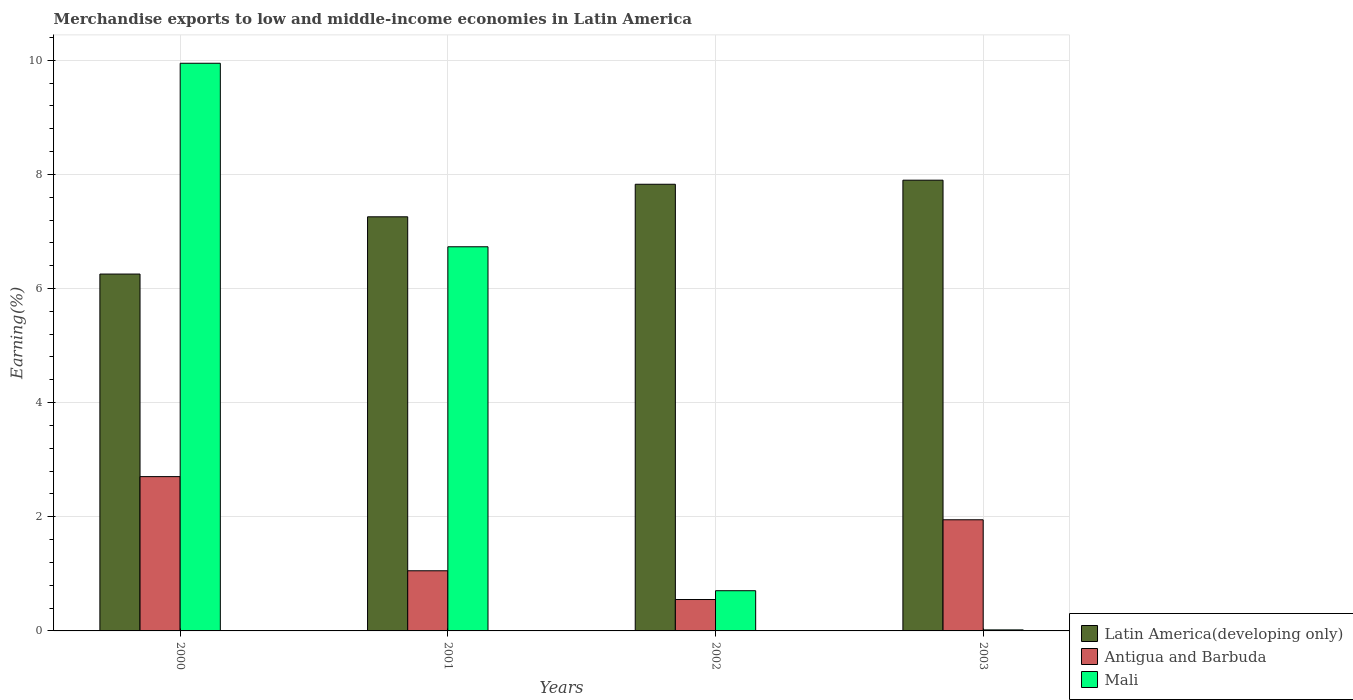How many groups of bars are there?
Offer a terse response. 4. Are the number of bars per tick equal to the number of legend labels?
Make the answer very short. Yes. Are the number of bars on each tick of the X-axis equal?
Offer a very short reply. Yes. How many bars are there on the 4th tick from the left?
Offer a terse response. 3. How many bars are there on the 3rd tick from the right?
Your answer should be compact. 3. What is the percentage of amount earned from merchandise exports in Antigua and Barbuda in 2003?
Your answer should be very brief. 1.95. Across all years, what is the maximum percentage of amount earned from merchandise exports in Antigua and Barbuda?
Offer a terse response. 2.7. Across all years, what is the minimum percentage of amount earned from merchandise exports in Mali?
Keep it short and to the point. 0.02. In which year was the percentage of amount earned from merchandise exports in Antigua and Barbuda maximum?
Offer a terse response. 2000. What is the total percentage of amount earned from merchandise exports in Latin America(developing only) in the graph?
Keep it short and to the point. 29.24. What is the difference between the percentage of amount earned from merchandise exports in Antigua and Barbuda in 2001 and that in 2002?
Offer a terse response. 0.5. What is the difference between the percentage of amount earned from merchandise exports in Latin America(developing only) in 2003 and the percentage of amount earned from merchandise exports in Mali in 2001?
Offer a very short reply. 1.17. What is the average percentage of amount earned from merchandise exports in Antigua and Barbuda per year?
Your answer should be compact. 1.56. In the year 2003, what is the difference between the percentage of amount earned from merchandise exports in Latin America(developing only) and percentage of amount earned from merchandise exports in Antigua and Barbuda?
Offer a very short reply. 5.95. In how many years, is the percentage of amount earned from merchandise exports in Latin America(developing only) greater than 6.8 %?
Offer a very short reply. 3. What is the ratio of the percentage of amount earned from merchandise exports in Antigua and Barbuda in 2000 to that in 2003?
Ensure brevity in your answer.  1.39. What is the difference between the highest and the second highest percentage of amount earned from merchandise exports in Latin America(developing only)?
Your answer should be very brief. 0.07. What is the difference between the highest and the lowest percentage of amount earned from merchandise exports in Latin America(developing only)?
Make the answer very short. 1.64. What does the 3rd bar from the left in 2001 represents?
Your answer should be very brief. Mali. What does the 1st bar from the right in 2003 represents?
Your answer should be compact. Mali. Is it the case that in every year, the sum of the percentage of amount earned from merchandise exports in Antigua and Barbuda and percentage of amount earned from merchandise exports in Latin America(developing only) is greater than the percentage of amount earned from merchandise exports in Mali?
Keep it short and to the point. No. How many bars are there?
Offer a terse response. 12. Are all the bars in the graph horizontal?
Your answer should be very brief. No. Are the values on the major ticks of Y-axis written in scientific E-notation?
Your answer should be very brief. No. Does the graph contain any zero values?
Your answer should be compact. No. Where does the legend appear in the graph?
Your answer should be compact. Bottom right. How many legend labels are there?
Ensure brevity in your answer.  3. How are the legend labels stacked?
Provide a succinct answer. Vertical. What is the title of the graph?
Your response must be concise. Merchandise exports to low and middle-income economies in Latin America. Does "Switzerland" appear as one of the legend labels in the graph?
Offer a terse response. No. What is the label or title of the Y-axis?
Offer a very short reply. Earning(%). What is the Earning(%) in Latin America(developing only) in 2000?
Ensure brevity in your answer.  6.25. What is the Earning(%) in Antigua and Barbuda in 2000?
Keep it short and to the point. 2.7. What is the Earning(%) of Mali in 2000?
Give a very brief answer. 9.95. What is the Earning(%) of Latin America(developing only) in 2001?
Give a very brief answer. 7.26. What is the Earning(%) of Antigua and Barbuda in 2001?
Provide a succinct answer. 1.05. What is the Earning(%) of Mali in 2001?
Ensure brevity in your answer.  6.73. What is the Earning(%) of Latin America(developing only) in 2002?
Make the answer very short. 7.83. What is the Earning(%) in Antigua and Barbuda in 2002?
Ensure brevity in your answer.  0.55. What is the Earning(%) of Mali in 2002?
Make the answer very short. 0.7. What is the Earning(%) of Latin America(developing only) in 2003?
Your answer should be very brief. 7.9. What is the Earning(%) of Antigua and Barbuda in 2003?
Provide a short and direct response. 1.95. What is the Earning(%) in Mali in 2003?
Make the answer very short. 0.02. Across all years, what is the maximum Earning(%) of Latin America(developing only)?
Give a very brief answer. 7.9. Across all years, what is the maximum Earning(%) of Antigua and Barbuda?
Provide a succinct answer. 2.7. Across all years, what is the maximum Earning(%) of Mali?
Offer a very short reply. 9.95. Across all years, what is the minimum Earning(%) of Latin America(developing only)?
Provide a succinct answer. 6.25. Across all years, what is the minimum Earning(%) of Antigua and Barbuda?
Ensure brevity in your answer.  0.55. Across all years, what is the minimum Earning(%) of Mali?
Offer a very short reply. 0.02. What is the total Earning(%) of Latin America(developing only) in the graph?
Your answer should be compact. 29.24. What is the total Earning(%) in Antigua and Barbuda in the graph?
Give a very brief answer. 6.26. What is the total Earning(%) of Mali in the graph?
Offer a very short reply. 17.4. What is the difference between the Earning(%) of Latin America(developing only) in 2000 and that in 2001?
Your response must be concise. -1. What is the difference between the Earning(%) of Antigua and Barbuda in 2000 and that in 2001?
Offer a very short reply. 1.65. What is the difference between the Earning(%) of Mali in 2000 and that in 2001?
Your answer should be very brief. 3.22. What is the difference between the Earning(%) of Latin America(developing only) in 2000 and that in 2002?
Your response must be concise. -1.57. What is the difference between the Earning(%) in Antigua and Barbuda in 2000 and that in 2002?
Make the answer very short. 2.15. What is the difference between the Earning(%) of Mali in 2000 and that in 2002?
Make the answer very short. 9.24. What is the difference between the Earning(%) of Latin America(developing only) in 2000 and that in 2003?
Your answer should be very brief. -1.65. What is the difference between the Earning(%) in Antigua and Barbuda in 2000 and that in 2003?
Offer a very short reply. 0.76. What is the difference between the Earning(%) of Mali in 2000 and that in 2003?
Your answer should be compact. 9.93. What is the difference between the Earning(%) in Latin America(developing only) in 2001 and that in 2002?
Offer a terse response. -0.57. What is the difference between the Earning(%) of Antigua and Barbuda in 2001 and that in 2002?
Provide a succinct answer. 0.5. What is the difference between the Earning(%) of Mali in 2001 and that in 2002?
Keep it short and to the point. 6.03. What is the difference between the Earning(%) in Latin America(developing only) in 2001 and that in 2003?
Your response must be concise. -0.64. What is the difference between the Earning(%) in Antigua and Barbuda in 2001 and that in 2003?
Your response must be concise. -0.89. What is the difference between the Earning(%) of Mali in 2001 and that in 2003?
Your response must be concise. 6.71. What is the difference between the Earning(%) of Latin America(developing only) in 2002 and that in 2003?
Provide a succinct answer. -0.07. What is the difference between the Earning(%) of Antigua and Barbuda in 2002 and that in 2003?
Keep it short and to the point. -1.4. What is the difference between the Earning(%) in Mali in 2002 and that in 2003?
Your response must be concise. 0.69. What is the difference between the Earning(%) of Latin America(developing only) in 2000 and the Earning(%) of Antigua and Barbuda in 2001?
Provide a succinct answer. 5.2. What is the difference between the Earning(%) in Latin America(developing only) in 2000 and the Earning(%) in Mali in 2001?
Provide a short and direct response. -0.48. What is the difference between the Earning(%) of Antigua and Barbuda in 2000 and the Earning(%) of Mali in 2001?
Give a very brief answer. -4.03. What is the difference between the Earning(%) in Latin America(developing only) in 2000 and the Earning(%) in Antigua and Barbuda in 2002?
Your answer should be very brief. 5.7. What is the difference between the Earning(%) of Latin America(developing only) in 2000 and the Earning(%) of Mali in 2002?
Your answer should be very brief. 5.55. What is the difference between the Earning(%) in Antigua and Barbuda in 2000 and the Earning(%) in Mali in 2002?
Your response must be concise. 2. What is the difference between the Earning(%) of Latin America(developing only) in 2000 and the Earning(%) of Antigua and Barbuda in 2003?
Provide a succinct answer. 4.31. What is the difference between the Earning(%) in Latin America(developing only) in 2000 and the Earning(%) in Mali in 2003?
Make the answer very short. 6.24. What is the difference between the Earning(%) of Antigua and Barbuda in 2000 and the Earning(%) of Mali in 2003?
Keep it short and to the point. 2.69. What is the difference between the Earning(%) of Latin America(developing only) in 2001 and the Earning(%) of Antigua and Barbuda in 2002?
Ensure brevity in your answer.  6.71. What is the difference between the Earning(%) of Latin America(developing only) in 2001 and the Earning(%) of Mali in 2002?
Make the answer very short. 6.55. What is the difference between the Earning(%) of Antigua and Barbuda in 2001 and the Earning(%) of Mali in 2002?
Make the answer very short. 0.35. What is the difference between the Earning(%) in Latin America(developing only) in 2001 and the Earning(%) in Antigua and Barbuda in 2003?
Your answer should be very brief. 5.31. What is the difference between the Earning(%) in Latin America(developing only) in 2001 and the Earning(%) in Mali in 2003?
Your answer should be very brief. 7.24. What is the difference between the Earning(%) in Antigua and Barbuda in 2001 and the Earning(%) in Mali in 2003?
Ensure brevity in your answer.  1.04. What is the difference between the Earning(%) of Latin America(developing only) in 2002 and the Earning(%) of Antigua and Barbuda in 2003?
Provide a succinct answer. 5.88. What is the difference between the Earning(%) of Latin America(developing only) in 2002 and the Earning(%) of Mali in 2003?
Offer a very short reply. 7.81. What is the difference between the Earning(%) of Antigua and Barbuda in 2002 and the Earning(%) of Mali in 2003?
Give a very brief answer. 0.53. What is the average Earning(%) in Latin America(developing only) per year?
Ensure brevity in your answer.  7.31. What is the average Earning(%) of Antigua and Barbuda per year?
Provide a succinct answer. 1.56. What is the average Earning(%) of Mali per year?
Give a very brief answer. 4.35. In the year 2000, what is the difference between the Earning(%) of Latin America(developing only) and Earning(%) of Antigua and Barbuda?
Your answer should be compact. 3.55. In the year 2000, what is the difference between the Earning(%) in Latin America(developing only) and Earning(%) in Mali?
Your answer should be very brief. -3.69. In the year 2000, what is the difference between the Earning(%) in Antigua and Barbuda and Earning(%) in Mali?
Ensure brevity in your answer.  -7.24. In the year 2001, what is the difference between the Earning(%) in Latin America(developing only) and Earning(%) in Antigua and Barbuda?
Make the answer very short. 6.2. In the year 2001, what is the difference between the Earning(%) of Latin America(developing only) and Earning(%) of Mali?
Your answer should be very brief. 0.53. In the year 2001, what is the difference between the Earning(%) in Antigua and Barbuda and Earning(%) in Mali?
Offer a very short reply. -5.68. In the year 2002, what is the difference between the Earning(%) of Latin America(developing only) and Earning(%) of Antigua and Barbuda?
Offer a terse response. 7.28. In the year 2002, what is the difference between the Earning(%) in Latin America(developing only) and Earning(%) in Mali?
Keep it short and to the point. 7.12. In the year 2002, what is the difference between the Earning(%) in Antigua and Barbuda and Earning(%) in Mali?
Your answer should be very brief. -0.15. In the year 2003, what is the difference between the Earning(%) of Latin America(developing only) and Earning(%) of Antigua and Barbuda?
Offer a very short reply. 5.95. In the year 2003, what is the difference between the Earning(%) of Latin America(developing only) and Earning(%) of Mali?
Your answer should be compact. 7.88. In the year 2003, what is the difference between the Earning(%) in Antigua and Barbuda and Earning(%) in Mali?
Keep it short and to the point. 1.93. What is the ratio of the Earning(%) of Latin America(developing only) in 2000 to that in 2001?
Ensure brevity in your answer.  0.86. What is the ratio of the Earning(%) in Antigua and Barbuda in 2000 to that in 2001?
Make the answer very short. 2.57. What is the ratio of the Earning(%) of Mali in 2000 to that in 2001?
Make the answer very short. 1.48. What is the ratio of the Earning(%) of Latin America(developing only) in 2000 to that in 2002?
Make the answer very short. 0.8. What is the ratio of the Earning(%) in Antigua and Barbuda in 2000 to that in 2002?
Provide a succinct answer. 4.91. What is the ratio of the Earning(%) of Mali in 2000 to that in 2002?
Your response must be concise. 14.12. What is the ratio of the Earning(%) of Latin America(developing only) in 2000 to that in 2003?
Keep it short and to the point. 0.79. What is the ratio of the Earning(%) in Antigua and Barbuda in 2000 to that in 2003?
Provide a short and direct response. 1.39. What is the ratio of the Earning(%) of Mali in 2000 to that in 2003?
Ensure brevity in your answer.  554.47. What is the ratio of the Earning(%) in Latin America(developing only) in 2001 to that in 2002?
Provide a short and direct response. 0.93. What is the ratio of the Earning(%) of Antigua and Barbuda in 2001 to that in 2002?
Ensure brevity in your answer.  1.92. What is the ratio of the Earning(%) of Mali in 2001 to that in 2002?
Make the answer very short. 9.56. What is the ratio of the Earning(%) of Latin America(developing only) in 2001 to that in 2003?
Give a very brief answer. 0.92. What is the ratio of the Earning(%) of Antigua and Barbuda in 2001 to that in 2003?
Provide a short and direct response. 0.54. What is the ratio of the Earning(%) in Mali in 2001 to that in 2003?
Make the answer very short. 375.23. What is the ratio of the Earning(%) of Latin America(developing only) in 2002 to that in 2003?
Make the answer very short. 0.99. What is the ratio of the Earning(%) of Antigua and Barbuda in 2002 to that in 2003?
Make the answer very short. 0.28. What is the ratio of the Earning(%) of Mali in 2002 to that in 2003?
Ensure brevity in your answer.  39.27. What is the difference between the highest and the second highest Earning(%) of Latin America(developing only)?
Make the answer very short. 0.07. What is the difference between the highest and the second highest Earning(%) in Antigua and Barbuda?
Ensure brevity in your answer.  0.76. What is the difference between the highest and the second highest Earning(%) in Mali?
Provide a short and direct response. 3.22. What is the difference between the highest and the lowest Earning(%) of Latin America(developing only)?
Provide a short and direct response. 1.65. What is the difference between the highest and the lowest Earning(%) in Antigua and Barbuda?
Provide a succinct answer. 2.15. What is the difference between the highest and the lowest Earning(%) in Mali?
Give a very brief answer. 9.93. 